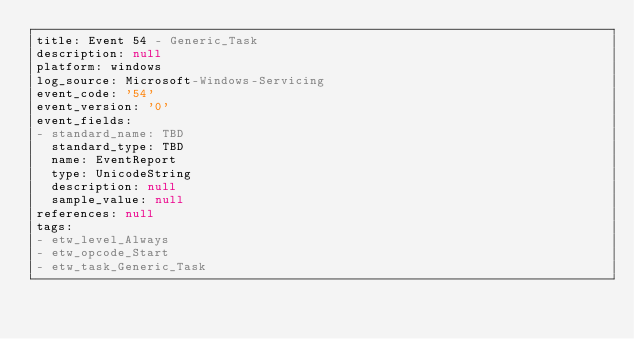<code> <loc_0><loc_0><loc_500><loc_500><_YAML_>title: Event 54 - Generic_Task
description: null
platform: windows
log_source: Microsoft-Windows-Servicing
event_code: '54'
event_version: '0'
event_fields:
- standard_name: TBD
  standard_type: TBD
  name: EventReport
  type: UnicodeString
  description: null
  sample_value: null
references: null
tags:
- etw_level_Always
- etw_opcode_Start
- etw_task_Generic_Task
</code> 